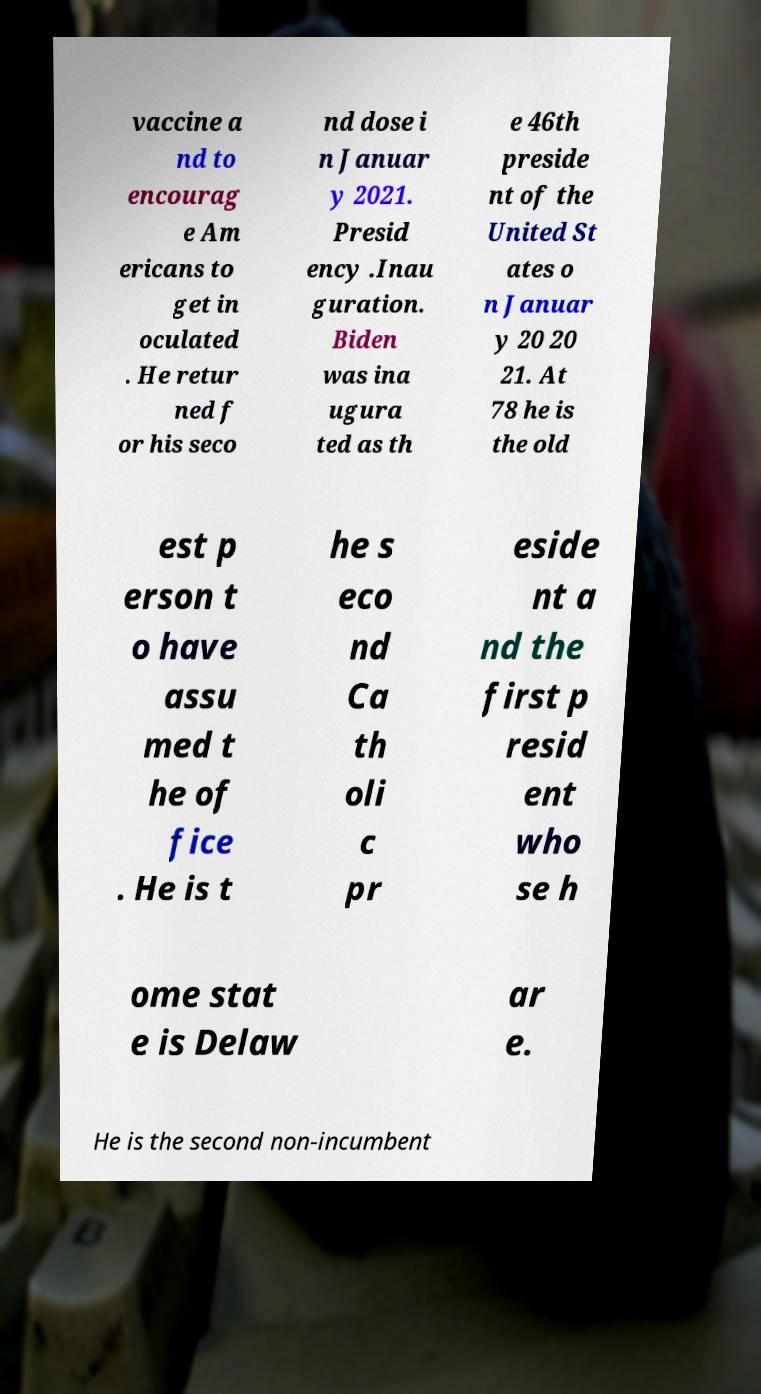Can you accurately transcribe the text from the provided image for me? vaccine a nd to encourag e Am ericans to get in oculated . He retur ned f or his seco nd dose i n Januar y 2021. Presid ency .Inau guration. Biden was ina ugura ted as th e 46th preside nt of the United St ates o n Januar y 20 20 21. At 78 he is the old est p erson t o have assu med t he of fice . He is t he s eco nd Ca th oli c pr eside nt a nd the first p resid ent who se h ome stat e is Delaw ar e. He is the second non-incumbent 